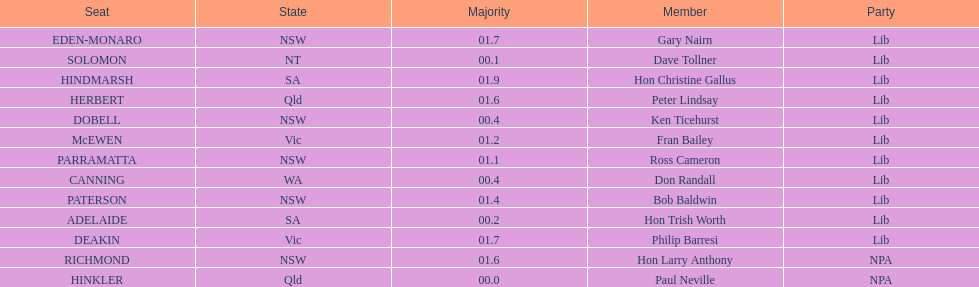What is the total of seats? 13. 